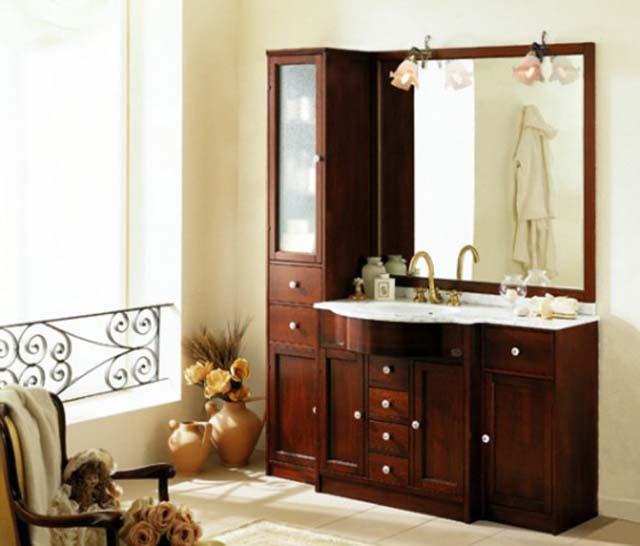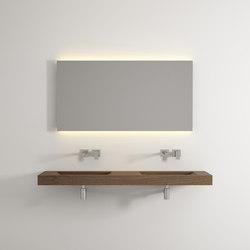The first image is the image on the left, the second image is the image on the right. Assess this claim about the two images: "Two mirrors hang over the sinks in the image on the right.". Correct or not? Answer yes or no. No. 